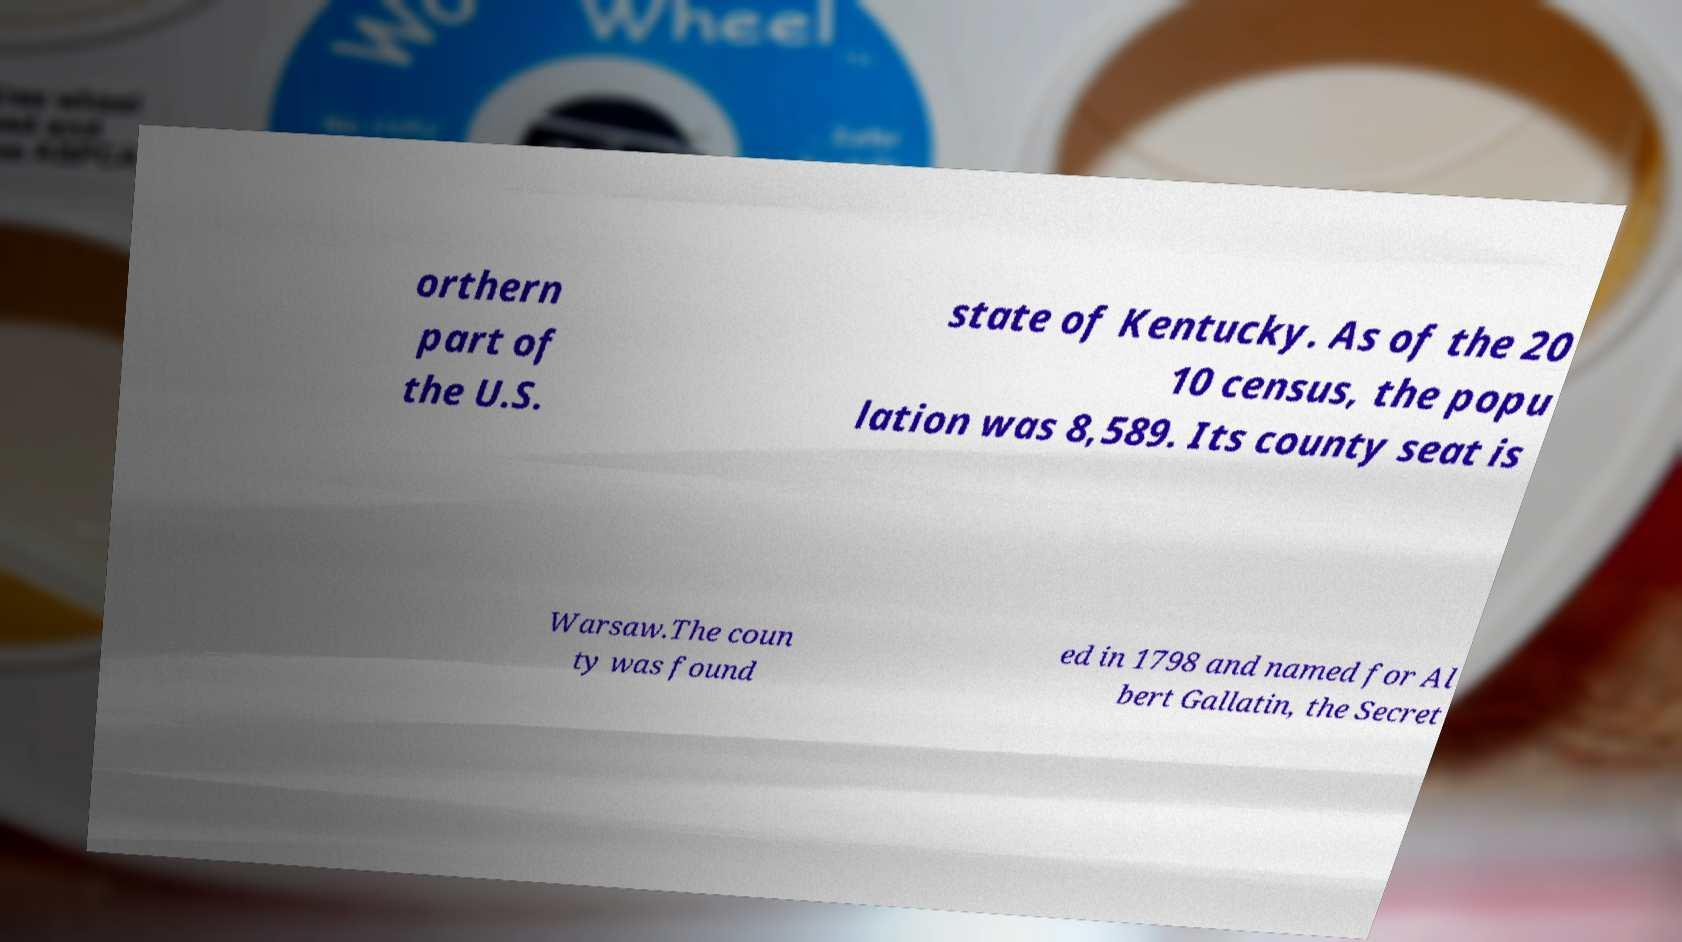Could you extract and type out the text from this image? orthern part of the U.S. state of Kentucky. As of the 20 10 census, the popu lation was 8,589. Its county seat is Warsaw.The coun ty was found ed in 1798 and named for Al bert Gallatin, the Secret 